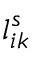<formula> <loc_0><loc_0><loc_500><loc_500>l _ { i k } ^ { s }</formula> 